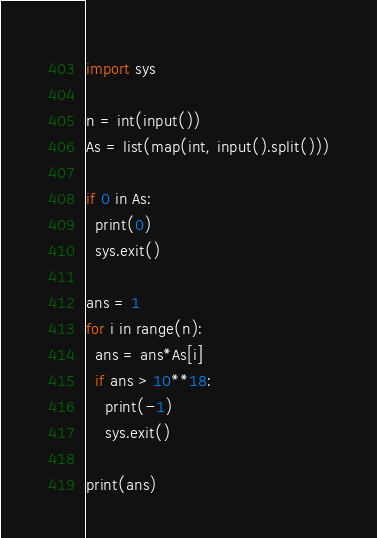Convert code to text. <code><loc_0><loc_0><loc_500><loc_500><_Python_>import sys
 
n = int(input())
As = list(map(int, input().split()))

if 0 in As:
  print(0)
  sys.exit()

ans = 1
for i in range(n):
  ans = ans*As[i]
  if ans > 10**18:
    print(-1)
    sys.exit()
 
print(ans)</code> 